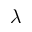<formula> <loc_0><loc_0><loc_500><loc_500>\lambda</formula> 